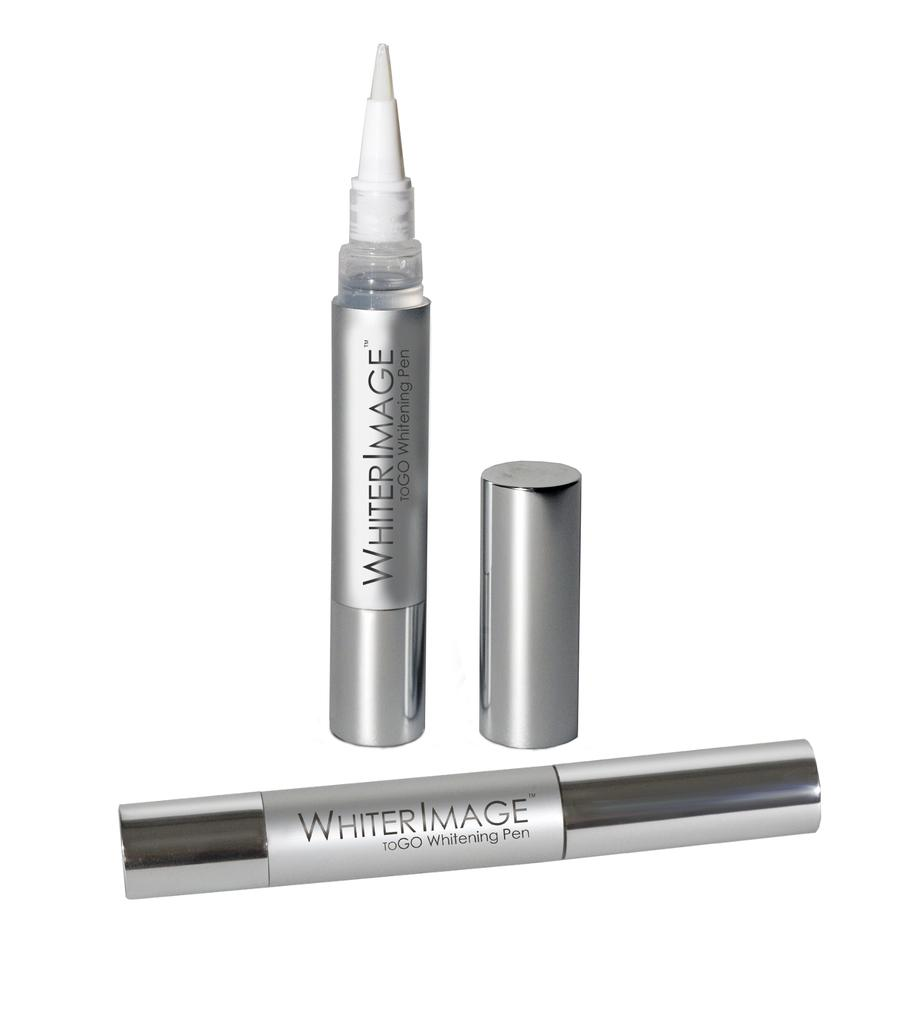Provide a one-sentence caption for the provided image. Whiter Image to go whitening pen in a picture. 